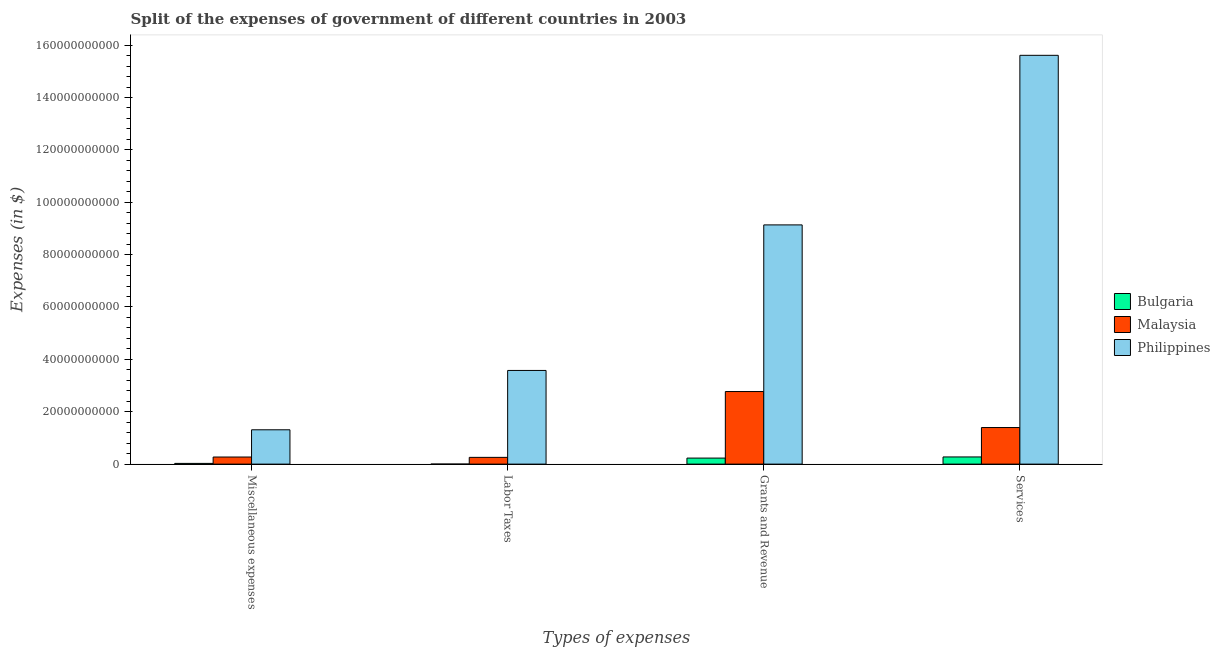How many different coloured bars are there?
Make the answer very short. 3. Are the number of bars per tick equal to the number of legend labels?
Keep it short and to the point. Yes. Are the number of bars on each tick of the X-axis equal?
Keep it short and to the point. Yes. How many bars are there on the 4th tick from the right?
Offer a terse response. 3. What is the label of the 3rd group of bars from the left?
Provide a short and direct response. Grants and Revenue. What is the amount spent on services in Bulgaria?
Give a very brief answer. 2.74e+09. Across all countries, what is the maximum amount spent on miscellaneous expenses?
Give a very brief answer. 1.31e+1. Across all countries, what is the minimum amount spent on labor taxes?
Your answer should be compact. 5.93e+06. In which country was the amount spent on labor taxes maximum?
Keep it short and to the point. Philippines. In which country was the amount spent on miscellaneous expenses minimum?
Ensure brevity in your answer.  Bulgaria. What is the total amount spent on miscellaneous expenses in the graph?
Provide a succinct answer. 1.61e+1. What is the difference between the amount spent on services in Bulgaria and that in Philippines?
Your response must be concise. -1.53e+11. What is the difference between the amount spent on labor taxes in Bulgaria and the amount spent on services in Philippines?
Provide a succinct answer. -1.56e+11. What is the average amount spent on miscellaneous expenses per country?
Keep it short and to the point. 5.36e+09. What is the difference between the amount spent on miscellaneous expenses and amount spent on services in Philippines?
Your answer should be very brief. -1.43e+11. In how many countries, is the amount spent on miscellaneous expenses greater than 148000000000 $?
Provide a succinct answer. 0. What is the ratio of the amount spent on miscellaneous expenses in Malaysia to that in Bulgaria?
Offer a terse response. 9.8. Is the amount spent on grants and revenue in Philippines less than that in Bulgaria?
Offer a very short reply. No. What is the difference between the highest and the second highest amount spent on services?
Your answer should be very brief. 1.42e+11. What is the difference between the highest and the lowest amount spent on grants and revenue?
Make the answer very short. 8.90e+1. In how many countries, is the amount spent on miscellaneous expenses greater than the average amount spent on miscellaneous expenses taken over all countries?
Your answer should be compact. 1. What does the 2nd bar from the left in Services represents?
Offer a terse response. Malaysia. Is it the case that in every country, the sum of the amount spent on miscellaneous expenses and amount spent on labor taxes is greater than the amount spent on grants and revenue?
Your answer should be very brief. No. Are all the bars in the graph horizontal?
Keep it short and to the point. No. What is the difference between two consecutive major ticks on the Y-axis?
Your answer should be compact. 2.00e+1. Are the values on the major ticks of Y-axis written in scientific E-notation?
Provide a short and direct response. No. Where does the legend appear in the graph?
Your response must be concise. Center right. How are the legend labels stacked?
Your answer should be very brief. Vertical. What is the title of the graph?
Keep it short and to the point. Split of the expenses of government of different countries in 2003. Does "Macao" appear as one of the legend labels in the graph?
Keep it short and to the point. No. What is the label or title of the X-axis?
Your response must be concise. Types of expenses. What is the label or title of the Y-axis?
Offer a very short reply. Expenses (in $). What is the Expenses (in $) of Bulgaria in Miscellaneous expenses?
Offer a terse response. 2.76e+08. What is the Expenses (in $) of Malaysia in Miscellaneous expenses?
Offer a terse response. 2.71e+09. What is the Expenses (in $) of Philippines in Miscellaneous expenses?
Offer a very short reply. 1.31e+1. What is the Expenses (in $) of Bulgaria in Labor Taxes?
Provide a short and direct response. 5.93e+06. What is the Expenses (in $) in Malaysia in Labor Taxes?
Offer a very short reply. 2.58e+09. What is the Expenses (in $) in Philippines in Labor Taxes?
Your answer should be very brief. 3.58e+1. What is the Expenses (in $) of Bulgaria in Grants and Revenue?
Offer a very short reply. 2.30e+09. What is the Expenses (in $) in Malaysia in Grants and Revenue?
Make the answer very short. 2.77e+1. What is the Expenses (in $) of Philippines in Grants and Revenue?
Keep it short and to the point. 9.14e+1. What is the Expenses (in $) of Bulgaria in Services?
Offer a very short reply. 2.74e+09. What is the Expenses (in $) in Malaysia in Services?
Offer a terse response. 1.40e+1. What is the Expenses (in $) of Philippines in Services?
Make the answer very short. 1.56e+11. Across all Types of expenses, what is the maximum Expenses (in $) of Bulgaria?
Ensure brevity in your answer.  2.74e+09. Across all Types of expenses, what is the maximum Expenses (in $) of Malaysia?
Give a very brief answer. 2.77e+1. Across all Types of expenses, what is the maximum Expenses (in $) in Philippines?
Offer a terse response. 1.56e+11. Across all Types of expenses, what is the minimum Expenses (in $) of Bulgaria?
Your answer should be compact. 5.93e+06. Across all Types of expenses, what is the minimum Expenses (in $) of Malaysia?
Keep it short and to the point. 2.58e+09. Across all Types of expenses, what is the minimum Expenses (in $) of Philippines?
Keep it short and to the point. 1.31e+1. What is the total Expenses (in $) in Bulgaria in the graph?
Keep it short and to the point. 5.32e+09. What is the total Expenses (in $) of Malaysia in the graph?
Provide a succinct answer. 4.70e+1. What is the total Expenses (in $) of Philippines in the graph?
Offer a very short reply. 2.96e+11. What is the difference between the Expenses (in $) in Bulgaria in Miscellaneous expenses and that in Labor Taxes?
Give a very brief answer. 2.70e+08. What is the difference between the Expenses (in $) in Malaysia in Miscellaneous expenses and that in Labor Taxes?
Provide a succinct answer. 1.30e+08. What is the difference between the Expenses (in $) of Philippines in Miscellaneous expenses and that in Labor Taxes?
Your answer should be compact. -2.27e+1. What is the difference between the Expenses (in $) in Bulgaria in Miscellaneous expenses and that in Grants and Revenue?
Keep it short and to the point. -2.03e+09. What is the difference between the Expenses (in $) in Malaysia in Miscellaneous expenses and that in Grants and Revenue?
Provide a short and direct response. -2.50e+1. What is the difference between the Expenses (in $) in Philippines in Miscellaneous expenses and that in Grants and Revenue?
Keep it short and to the point. -7.82e+1. What is the difference between the Expenses (in $) in Bulgaria in Miscellaneous expenses and that in Services?
Ensure brevity in your answer.  -2.46e+09. What is the difference between the Expenses (in $) in Malaysia in Miscellaneous expenses and that in Services?
Provide a short and direct response. -1.13e+1. What is the difference between the Expenses (in $) of Philippines in Miscellaneous expenses and that in Services?
Your answer should be compact. -1.43e+11. What is the difference between the Expenses (in $) of Bulgaria in Labor Taxes and that in Grants and Revenue?
Provide a short and direct response. -2.30e+09. What is the difference between the Expenses (in $) of Malaysia in Labor Taxes and that in Grants and Revenue?
Your response must be concise. -2.51e+1. What is the difference between the Expenses (in $) of Philippines in Labor Taxes and that in Grants and Revenue?
Offer a terse response. -5.56e+1. What is the difference between the Expenses (in $) in Bulgaria in Labor Taxes and that in Services?
Make the answer very short. -2.73e+09. What is the difference between the Expenses (in $) of Malaysia in Labor Taxes and that in Services?
Ensure brevity in your answer.  -1.14e+1. What is the difference between the Expenses (in $) in Philippines in Labor Taxes and that in Services?
Give a very brief answer. -1.20e+11. What is the difference between the Expenses (in $) in Bulgaria in Grants and Revenue and that in Services?
Ensure brevity in your answer.  -4.37e+08. What is the difference between the Expenses (in $) of Malaysia in Grants and Revenue and that in Services?
Provide a succinct answer. 1.37e+1. What is the difference between the Expenses (in $) of Philippines in Grants and Revenue and that in Services?
Your answer should be very brief. -6.48e+1. What is the difference between the Expenses (in $) of Bulgaria in Miscellaneous expenses and the Expenses (in $) of Malaysia in Labor Taxes?
Give a very brief answer. -2.30e+09. What is the difference between the Expenses (in $) in Bulgaria in Miscellaneous expenses and the Expenses (in $) in Philippines in Labor Taxes?
Ensure brevity in your answer.  -3.55e+1. What is the difference between the Expenses (in $) of Malaysia in Miscellaneous expenses and the Expenses (in $) of Philippines in Labor Taxes?
Provide a succinct answer. -3.31e+1. What is the difference between the Expenses (in $) in Bulgaria in Miscellaneous expenses and the Expenses (in $) in Malaysia in Grants and Revenue?
Give a very brief answer. -2.74e+1. What is the difference between the Expenses (in $) in Bulgaria in Miscellaneous expenses and the Expenses (in $) in Philippines in Grants and Revenue?
Ensure brevity in your answer.  -9.11e+1. What is the difference between the Expenses (in $) of Malaysia in Miscellaneous expenses and the Expenses (in $) of Philippines in Grants and Revenue?
Your answer should be very brief. -8.86e+1. What is the difference between the Expenses (in $) of Bulgaria in Miscellaneous expenses and the Expenses (in $) of Malaysia in Services?
Give a very brief answer. -1.37e+1. What is the difference between the Expenses (in $) of Bulgaria in Miscellaneous expenses and the Expenses (in $) of Philippines in Services?
Offer a terse response. -1.56e+11. What is the difference between the Expenses (in $) in Malaysia in Miscellaneous expenses and the Expenses (in $) in Philippines in Services?
Provide a short and direct response. -1.53e+11. What is the difference between the Expenses (in $) in Bulgaria in Labor Taxes and the Expenses (in $) in Malaysia in Grants and Revenue?
Offer a terse response. -2.77e+1. What is the difference between the Expenses (in $) of Bulgaria in Labor Taxes and the Expenses (in $) of Philippines in Grants and Revenue?
Make the answer very short. -9.13e+1. What is the difference between the Expenses (in $) of Malaysia in Labor Taxes and the Expenses (in $) of Philippines in Grants and Revenue?
Provide a succinct answer. -8.88e+1. What is the difference between the Expenses (in $) of Bulgaria in Labor Taxes and the Expenses (in $) of Malaysia in Services?
Ensure brevity in your answer.  -1.40e+1. What is the difference between the Expenses (in $) of Bulgaria in Labor Taxes and the Expenses (in $) of Philippines in Services?
Offer a very short reply. -1.56e+11. What is the difference between the Expenses (in $) of Malaysia in Labor Taxes and the Expenses (in $) of Philippines in Services?
Provide a short and direct response. -1.54e+11. What is the difference between the Expenses (in $) of Bulgaria in Grants and Revenue and the Expenses (in $) of Malaysia in Services?
Offer a terse response. -1.17e+1. What is the difference between the Expenses (in $) of Bulgaria in Grants and Revenue and the Expenses (in $) of Philippines in Services?
Provide a succinct answer. -1.54e+11. What is the difference between the Expenses (in $) of Malaysia in Grants and Revenue and the Expenses (in $) of Philippines in Services?
Your answer should be compact. -1.28e+11. What is the average Expenses (in $) in Bulgaria per Types of expenses?
Offer a very short reply. 1.33e+09. What is the average Expenses (in $) of Malaysia per Types of expenses?
Give a very brief answer. 1.17e+1. What is the average Expenses (in $) in Philippines per Types of expenses?
Ensure brevity in your answer.  7.41e+1. What is the difference between the Expenses (in $) in Bulgaria and Expenses (in $) in Malaysia in Miscellaneous expenses?
Give a very brief answer. -2.43e+09. What is the difference between the Expenses (in $) in Bulgaria and Expenses (in $) in Philippines in Miscellaneous expenses?
Provide a short and direct response. -1.28e+1. What is the difference between the Expenses (in $) of Malaysia and Expenses (in $) of Philippines in Miscellaneous expenses?
Your answer should be very brief. -1.04e+1. What is the difference between the Expenses (in $) in Bulgaria and Expenses (in $) in Malaysia in Labor Taxes?
Offer a terse response. -2.57e+09. What is the difference between the Expenses (in $) in Bulgaria and Expenses (in $) in Philippines in Labor Taxes?
Give a very brief answer. -3.58e+1. What is the difference between the Expenses (in $) of Malaysia and Expenses (in $) of Philippines in Labor Taxes?
Provide a short and direct response. -3.32e+1. What is the difference between the Expenses (in $) of Bulgaria and Expenses (in $) of Malaysia in Grants and Revenue?
Provide a short and direct response. -2.54e+1. What is the difference between the Expenses (in $) in Bulgaria and Expenses (in $) in Philippines in Grants and Revenue?
Keep it short and to the point. -8.90e+1. What is the difference between the Expenses (in $) in Malaysia and Expenses (in $) in Philippines in Grants and Revenue?
Offer a terse response. -6.36e+1. What is the difference between the Expenses (in $) of Bulgaria and Expenses (in $) of Malaysia in Services?
Your answer should be very brief. -1.12e+1. What is the difference between the Expenses (in $) of Bulgaria and Expenses (in $) of Philippines in Services?
Your answer should be compact. -1.53e+11. What is the difference between the Expenses (in $) of Malaysia and Expenses (in $) of Philippines in Services?
Ensure brevity in your answer.  -1.42e+11. What is the ratio of the Expenses (in $) in Bulgaria in Miscellaneous expenses to that in Labor Taxes?
Ensure brevity in your answer.  46.57. What is the ratio of the Expenses (in $) of Malaysia in Miscellaneous expenses to that in Labor Taxes?
Provide a succinct answer. 1.05. What is the ratio of the Expenses (in $) of Philippines in Miscellaneous expenses to that in Labor Taxes?
Give a very brief answer. 0.37. What is the ratio of the Expenses (in $) in Bulgaria in Miscellaneous expenses to that in Grants and Revenue?
Keep it short and to the point. 0.12. What is the ratio of the Expenses (in $) of Malaysia in Miscellaneous expenses to that in Grants and Revenue?
Your answer should be very brief. 0.1. What is the ratio of the Expenses (in $) of Philippines in Miscellaneous expenses to that in Grants and Revenue?
Offer a terse response. 0.14. What is the ratio of the Expenses (in $) in Bulgaria in Miscellaneous expenses to that in Services?
Make the answer very short. 0.1. What is the ratio of the Expenses (in $) of Malaysia in Miscellaneous expenses to that in Services?
Offer a terse response. 0.19. What is the ratio of the Expenses (in $) of Philippines in Miscellaneous expenses to that in Services?
Give a very brief answer. 0.08. What is the ratio of the Expenses (in $) of Bulgaria in Labor Taxes to that in Grants and Revenue?
Keep it short and to the point. 0. What is the ratio of the Expenses (in $) in Malaysia in Labor Taxes to that in Grants and Revenue?
Offer a terse response. 0.09. What is the ratio of the Expenses (in $) in Philippines in Labor Taxes to that in Grants and Revenue?
Your response must be concise. 0.39. What is the ratio of the Expenses (in $) in Bulgaria in Labor Taxes to that in Services?
Provide a succinct answer. 0. What is the ratio of the Expenses (in $) of Malaysia in Labor Taxes to that in Services?
Keep it short and to the point. 0.18. What is the ratio of the Expenses (in $) of Philippines in Labor Taxes to that in Services?
Your answer should be very brief. 0.23. What is the ratio of the Expenses (in $) of Bulgaria in Grants and Revenue to that in Services?
Provide a succinct answer. 0.84. What is the ratio of the Expenses (in $) in Malaysia in Grants and Revenue to that in Services?
Provide a short and direct response. 1.98. What is the ratio of the Expenses (in $) of Philippines in Grants and Revenue to that in Services?
Offer a terse response. 0.59. What is the difference between the highest and the second highest Expenses (in $) in Bulgaria?
Offer a very short reply. 4.37e+08. What is the difference between the highest and the second highest Expenses (in $) of Malaysia?
Offer a terse response. 1.37e+1. What is the difference between the highest and the second highest Expenses (in $) of Philippines?
Your answer should be compact. 6.48e+1. What is the difference between the highest and the lowest Expenses (in $) of Bulgaria?
Your response must be concise. 2.73e+09. What is the difference between the highest and the lowest Expenses (in $) in Malaysia?
Your response must be concise. 2.51e+1. What is the difference between the highest and the lowest Expenses (in $) in Philippines?
Offer a very short reply. 1.43e+11. 